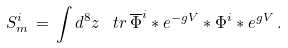Convert formula to latex. <formula><loc_0><loc_0><loc_500><loc_500>S ^ { i } _ { m } \, = \, \int d ^ { 8 } z \, \ t r \, \overline { \Phi } ^ { i } * e ^ { - g V } * \Phi ^ { i } * e ^ { g V } \, .</formula> 